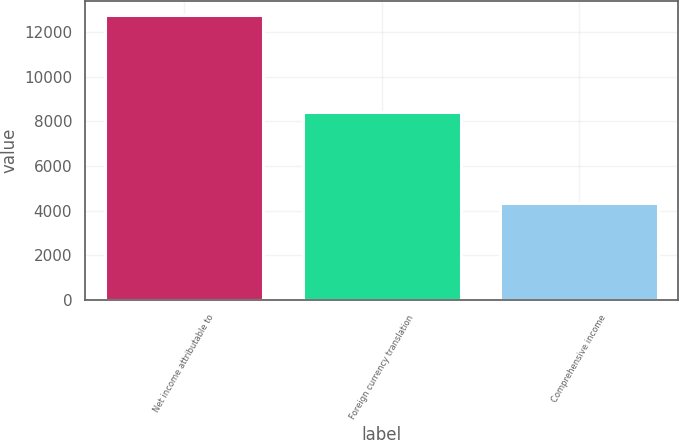Convert chart. <chart><loc_0><loc_0><loc_500><loc_500><bar_chart><fcel>Net income attributable to<fcel>Foreign currency translation<fcel>Comprehensive income<nl><fcel>12752<fcel>8417<fcel>4335<nl></chart> 